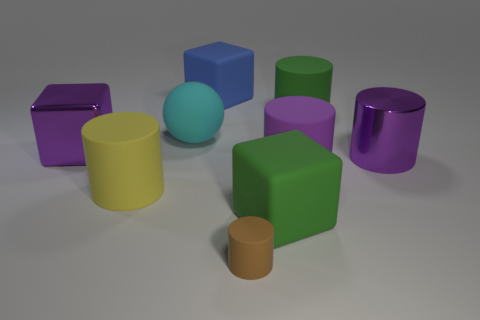Subtract all large purple cylinders. How many cylinders are left? 3 Subtract all green cylinders. How many cylinders are left? 4 Subtract all spheres. How many objects are left? 8 Subtract 3 blocks. How many blocks are left? 0 Subtract 0 red cylinders. How many objects are left? 9 Subtract all green cylinders. Subtract all blue balls. How many cylinders are left? 4 Subtract all gray cubes. How many yellow cylinders are left? 1 Subtract all brown shiny cubes. Subtract all large cyan balls. How many objects are left? 8 Add 4 small rubber cylinders. How many small rubber cylinders are left? 5 Add 6 purple shiny objects. How many purple shiny objects exist? 8 